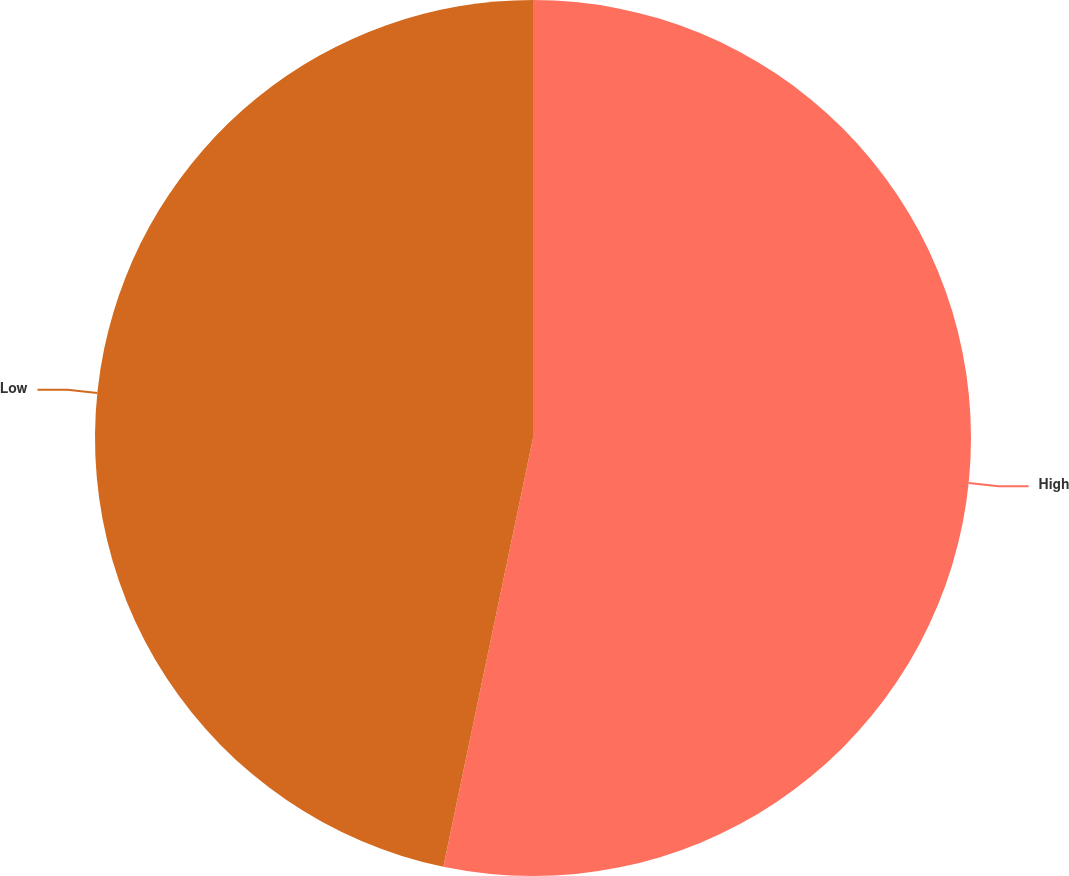Convert chart to OTSL. <chart><loc_0><loc_0><loc_500><loc_500><pie_chart><fcel>High<fcel>Low<nl><fcel>53.28%<fcel>46.72%<nl></chart> 